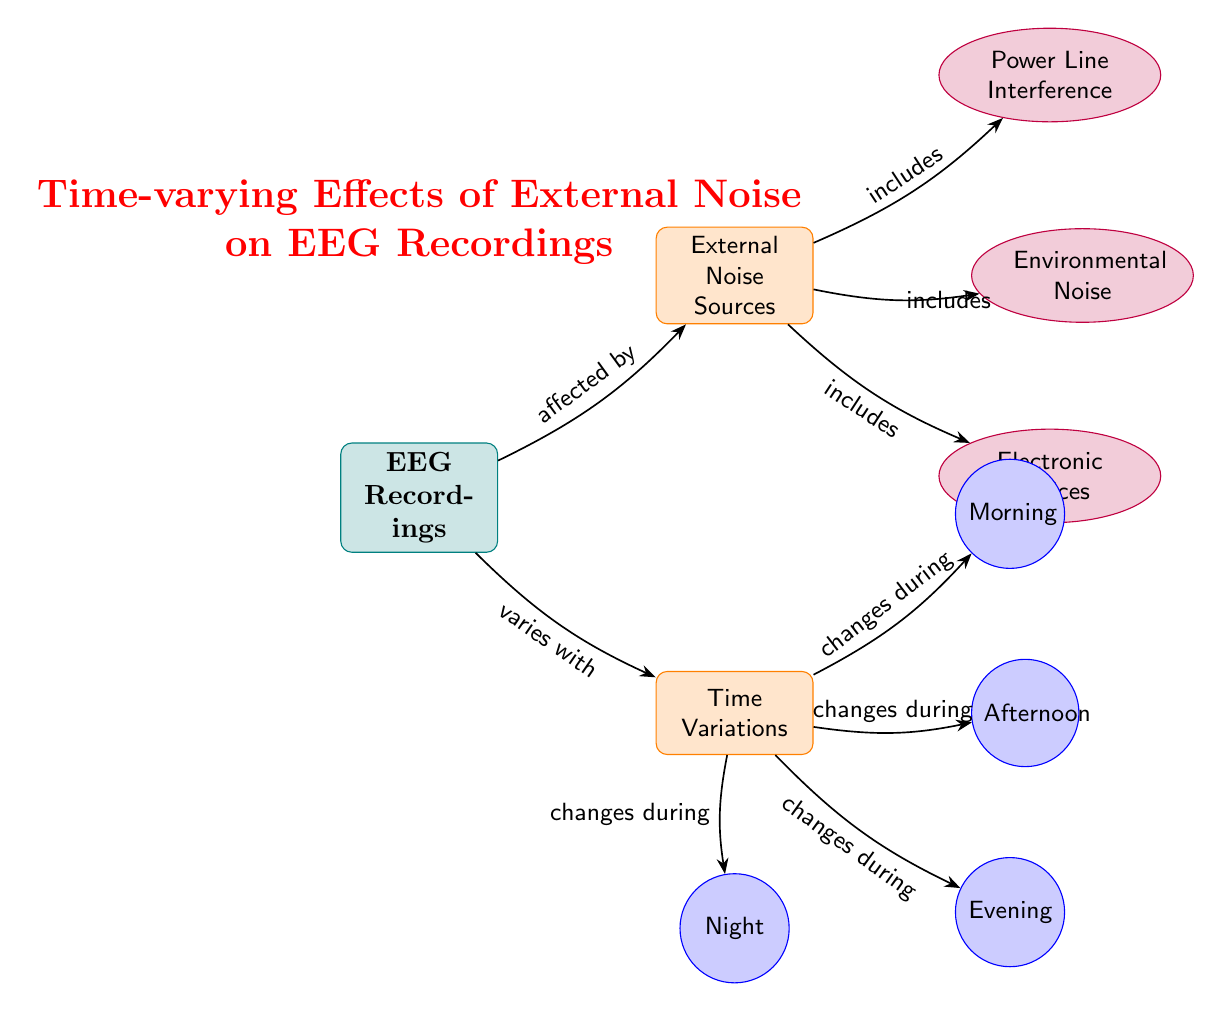What is the main subject of the diagram? The main subject node at the center of the diagram is labeled "EEG Recordings," which indicates that the diagram focuses on this topic.
Answer: EEG Recordings How many external noise sources are listed? The diagram contains three subcategory nodes under "External Noise Sources": Power Line Interference, Environmental Noise, and Electronic Devices. Therefore, there are three sources listed.
Answer: 3 What do the edges from "EEG Recordings" signify? The edges that connect "EEG Recordings" to "External Noise Sources" and "Time Variations" indicate that EEG recordings are affected by external noise sources and vary with time.
Answer: affected by and varies with During which time period does the diagram indicate changes? The diagram specifies four time nodes: Morning, Afternoon, Evening, and Night. Each of these time periods is associated with changes in the recording variations.
Answer: Morning, Afternoon, Evening, Night Which external noise source is labeled "Environmental Noise"? The second subcategory node under "External Noise Sources" is labeled "Environmental Noise," directly indicating that this noise source is part of the categories that affect EEG recordings.
Answer: Environmental Noise What is the relationship between "External Noise Sources" and "Power Line Interference"? The edge from "External Noise Sources" to "Power Line Interference" shows that Power Line Interference is included as one of the types of external noise sources affecting EEG recordings.
Answer: includes What happens to "EEG Recordings" during the Evening? According to the edges leading from "Time Variations," the EEG recordings are noted to change during the Evening time period, indicating a specific variation at that time.
Answer: changes during Evening How many time periods are depicted in the diagram? The diagram shows four distinct time periods: Morning, Afternoon, Evening, and Night, which are displayed as time nodes connected to the "Time Variations" category.
Answer: 4 What can be inferred about "Electronic Devices" in relation to EEG? "Electronic Devices" falls under "External Noise Sources," indicating that these devices contribute to the noise that can affect the accuracy of EEG recordings.
Answer: contributes to noise What effect does "Environmental Noise" have according to its relation in the diagram? "Environmental Noise" influences the quality of "EEG Recordings," as it is categorized under external noise sources that affect these recordings.
Answer: influences EEG quality 